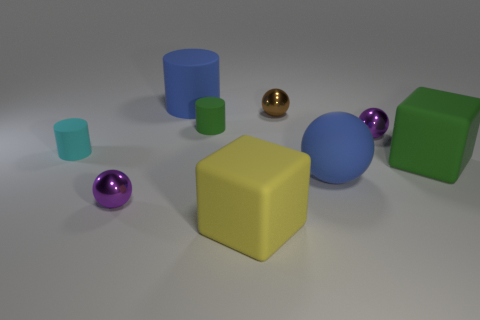How does the lighting in the image affect the appearance of the objects? The lighting plays a crucial role in this image. It's soft and diffused, preventing harsh shadows and therefore accentuating the different textures of the objects. Shiny objects, like the golden and purple spheres, have noticeable highlights and reflections, while the matte objects absorb light, giving a flatter appearance. This creates a sense of depth and brings out the dimensionality of the scene. 